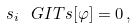<formula> <loc_0><loc_0><loc_500><loc_500>s _ { i } \ G I T s [ \varphi ] = 0 \, ,</formula> 